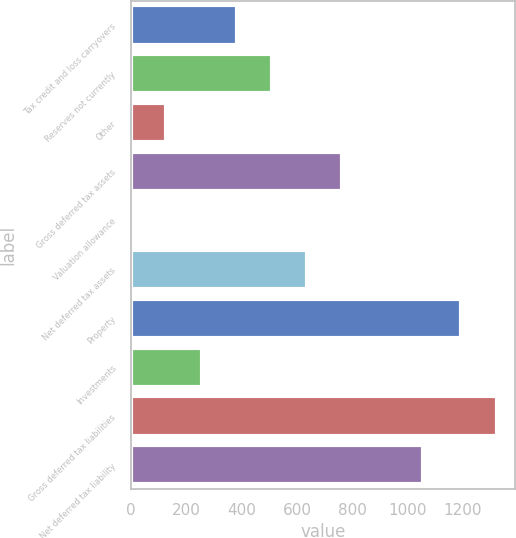<chart> <loc_0><loc_0><loc_500><loc_500><bar_chart><fcel>Tax credit and loss carryovers<fcel>Reserves not currently<fcel>Other<fcel>Gross deferred tax assets<fcel>Valuation allowance<fcel>Net deferred tax assets<fcel>Property<fcel>Investments<fcel>Gross deferred tax liabilities<fcel>Net deferred tax liability<nl><fcel>382.02<fcel>509.06<fcel>127.94<fcel>763.14<fcel>0.9<fcel>636.1<fcel>1194.7<fcel>254.98<fcel>1321.74<fcel>1056.2<nl></chart> 